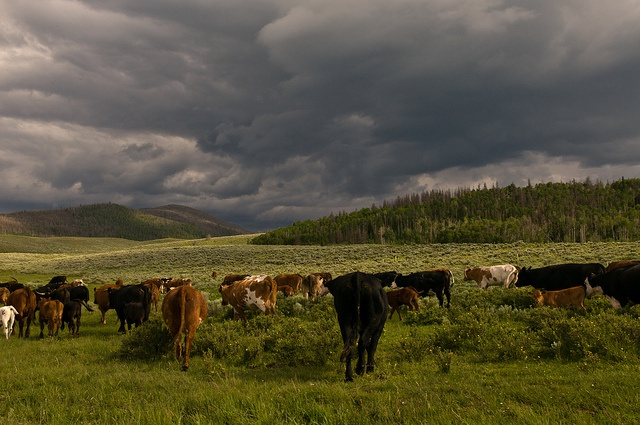Describe the objects in this image and their specific colors. I can see cow in darkgray, black, olive, and maroon tones, cow in darkgray, black, and olive tones, cow in darkgray, black, maroon, olive, and brown tones, cow in darkgray, black, maroon, and brown tones, and cow in darkgray, black, and olive tones in this image. 